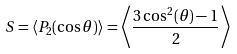Convert formula to latex. <formula><loc_0><loc_0><loc_500><loc_500>S = \langle P _ { 2 } ( \cos \theta ) \rangle = \left \langle { \frac { 3 \cos ^ { 2 } ( \theta ) - 1 } { 2 } } \right \rangle</formula> 